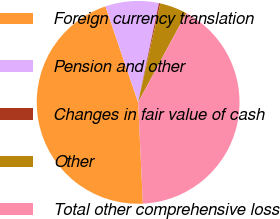<chart> <loc_0><loc_0><loc_500><loc_500><pie_chart><fcel>Foreign currency translation<fcel>Pension and other<fcel>Changes in fair value of cash<fcel>Other<fcel>Total other comprehensive loss<nl><fcel>45.52%<fcel>8.52%<fcel>0.22%<fcel>4.37%<fcel>41.37%<nl></chart> 